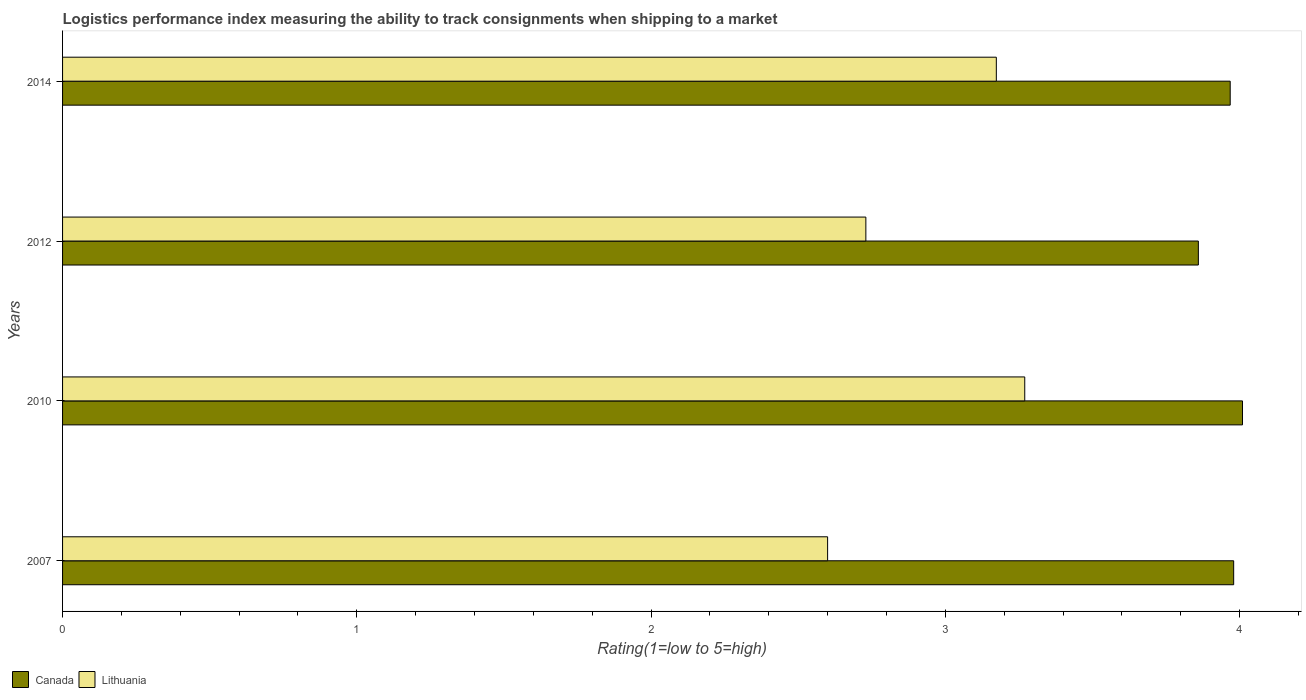How many groups of bars are there?
Provide a succinct answer. 4. Are the number of bars on each tick of the Y-axis equal?
Provide a succinct answer. Yes. How many bars are there on the 3rd tick from the top?
Ensure brevity in your answer.  2. In how many cases, is the number of bars for a given year not equal to the number of legend labels?
Keep it short and to the point. 0. What is the Logistic performance index in Lithuania in 2012?
Your answer should be compact. 2.73. Across all years, what is the maximum Logistic performance index in Canada?
Your response must be concise. 4.01. Across all years, what is the minimum Logistic performance index in Canada?
Provide a short and direct response. 3.86. In which year was the Logistic performance index in Canada minimum?
Keep it short and to the point. 2012. What is the total Logistic performance index in Lithuania in the graph?
Your response must be concise. 11.77. What is the difference between the Logistic performance index in Lithuania in 2010 and that in 2012?
Offer a terse response. 0.54. What is the difference between the Logistic performance index in Lithuania in 2014 and the Logistic performance index in Canada in 2007?
Provide a short and direct response. -0.81. What is the average Logistic performance index in Canada per year?
Make the answer very short. 3.95. In the year 2014, what is the difference between the Logistic performance index in Lithuania and Logistic performance index in Canada?
Keep it short and to the point. -0.79. What is the ratio of the Logistic performance index in Lithuania in 2007 to that in 2014?
Your answer should be compact. 0.82. What is the difference between the highest and the second highest Logistic performance index in Canada?
Provide a succinct answer. 0.03. What is the difference between the highest and the lowest Logistic performance index in Canada?
Keep it short and to the point. 0.15. In how many years, is the Logistic performance index in Canada greater than the average Logistic performance index in Canada taken over all years?
Ensure brevity in your answer.  3. What does the 2nd bar from the top in 2010 represents?
Offer a very short reply. Canada. What does the 2nd bar from the bottom in 2007 represents?
Keep it short and to the point. Lithuania. How many bars are there?
Make the answer very short. 8. How many years are there in the graph?
Offer a terse response. 4. Are the values on the major ticks of X-axis written in scientific E-notation?
Give a very brief answer. No. Does the graph contain any zero values?
Provide a short and direct response. No. Does the graph contain grids?
Provide a succinct answer. No. How many legend labels are there?
Offer a very short reply. 2. What is the title of the graph?
Your response must be concise. Logistics performance index measuring the ability to track consignments when shipping to a market. What is the label or title of the X-axis?
Offer a terse response. Rating(1=low to 5=high). What is the label or title of the Y-axis?
Ensure brevity in your answer.  Years. What is the Rating(1=low to 5=high) in Canada in 2007?
Provide a short and direct response. 3.98. What is the Rating(1=low to 5=high) in Canada in 2010?
Keep it short and to the point. 4.01. What is the Rating(1=low to 5=high) in Lithuania in 2010?
Your answer should be compact. 3.27. What is the Rating(1=low to 5=high) of Canada in 2012?
Keep it short and to the point. 3.86. What is the Rating(1=low to 5=high) of Lithuania in 2012?
Ensure brevity in your answer.  2.73. What is the Rating(1=low to 5=high) in Canada in 2014?
Offer a terse response. 3.97. What is the Rating(1=low to 5=high) of Lithuania in 2014?
Ensure brevity in your answer.  3.17. Across all years, what is the maximum Rating(1=low to 5=high) in Canada?
Offer a very short reply. 4.01. Across all years, what is the maximum Rating(1=low to 5=high) in Lithuania?
Offer a terse response. 3.27. Across all years, what is the minimum Rating(1=low to 5=high) in Canada?
Your answer should be very brief. 3.86. What is the total Rating(1=low to 5=high) of Canada in the graph?
Offer a terse response. 15.82. What is the total Rating(1=low to 5=high) of Lithuania in the graph?
Keep it short and to the point. 11.77. What is the difference between the Rating(1=low to 5=high) of Canada in 2007 and that in 2010?
Ensure brevity in your answer.  -0.03. What is the difference between the Rating(1=low to 5=high) in Lithuania in 2007 and that in 2010?
Provide a short and direct response. -0.67. What is the difference between the Rating(1=low to 5=high) of Canada in 2007 and that in 2012?
Provide a short and direct response. 0.12. What is the difference between the Rating(1=low to 5=high) of Lithuania in 2007 and that in 2012?
Your answer should be very brief. -0.13. What is the difference between the Rating(1=low to 5=high) of Canada in 2007 and that in 2014?
Provide a succinct answer. 0.01. What is the difference between the Rating(1=low to 5=high) in Lithuania in 2007 and that in 2014?
Provide a short and direct response. -0.57. What is the difference between the Rating(1=low to 5=high) in Lithuania in 2010 and that in 2012?
Give a very brief answer. 0.54. What is the difference between the Rating(1=low to 5=high) in Canada in 2010 and that in 2014?
Give a very brief answer. 0.04. What is the difference between the Rating(1=low to 5=high) in Lithuania in 2010 and that in 2014?
Provide a short and direct response. 0.1. What is the difference between the Rating(1=low to 5=high) of Canada in 2012 and that in 2014?
Provide a succinct answer. -0.11. What is the difference between the Rating(1=low to 5=high) in Lithuania in 2012 and that in 2014?
Make the answer very short. -0.44. What is the difference between the Rating(1=low to 5=high) in Canada in 2007 and the Rating(1=low to 5=high) in Lithuania in 2010?
Offer a very short reply. 0.71. What is the difference between the Rating(1=low to 5=high) of Canada in 2007 and the Rating(1=low to 5=high) of Lithuania in 2012?
Offer a terse response. 1.25. What is the difference between the Rating(1=low to 5=high) in Canada in 2007 and the Rating(1=low to 5=high) in Lithuania in 2014?
Ensure brevity in your answer.  0.81. What is the difference between the Rating(1=low to 5=high) in Canada in 2010 and the Rating(1=low to 5=high) in Lithuania in 2012?
Offer a terse response. 1.28. What is the difference between the Rating(1=low to 5=high) of Canada in 2010 and the Rating(1=low to 5=high) of Lithuania in 2014?
Offer a very short reply. 0.84. What is the difference between the Rating(1=low to 5=high) of Canada in 2012 and the Rating(1=low to 5=high) of Lithuania in 2014?
Provide a short and direct response. 0.69. What is the average Rating(1=low to 5=high) in Canada per year?
Ensure brevity in your answer.  3.95. What is the average Rating(1=low to 5=high) of Lithuania per year?
Ensure brevity in your answer.  2.94. In the year 2007, what is the difference between the Rating(1=low to 5=high) in Canada and Rating(1=low to 5=high) in Lithuania?
Provide a short and direct response. 1.38. In the year 2010, what is the difference between the Rating(1=low to 5=high) of Canada and Rating(1=low to 5=high) of Lithuania?
Provide a succinct answer. 0.74. In the year 2012, what is the difference between the Rating(1=low to 5=high) in Canada and Rating(1=low to 5=high) in Lithuania?
Offer a terse response. 1.13. In the year 2014, what is the difference between the Rating(1=low to 5=high) of Canada and Rating(1=low to 5=high) of Lithuania?
Ensure brevity in your answer.  0.79. What is the ratio of the Rating(1=low to 5=high) in Lithuania in 2007 to that in 2010?
Make the answer very short. 0.8. What is the ratio of the Rating(1=low to 5=high) in Canada in 2007 to that in 2012?
Provide a short and direct response. 1.03. What is the ratio of the Rating(1=low to 5=high) in Canada in 2007 to that in 2014?
Your response must be concise. 1. What is the ratio of the Rating(1=low to 5=high) in Lithuania in 2007 to that in 2014?
Give a very brief answer. 0.82. What is the ratio of the Rating(1=low to 5=high) in Canada in 2010 to that in 2012?
Your answer should be very brief. 1.04. What is the ratio of the Rating(1=low to 5=high) of Lithuania in 2010 to that in 2012?
Provide a short and direct response. 1.2. What is the ratio of the Rating(1=low to 5=high) in Canada in 2010 to that in 2014?
Keep it short and to the point. 1.01. What is the ratio of the Rating(1=low to 5=high) of Lithuania in 2010 to that in 2014?
Offer a terse response. 1.03. What is the ratio of the Rating(1=low to 5=high) of Canada in 2012 to that in 2014?
Offer a terse response. 0.97. What is the ratio of the Rating(1=low to 5=high) in Lithuania in 2012 to that in 2014?
Provide a succinct answer. 0.86. What is the difference between the highest and the second highest Rating(1=low to 5=high) of Canada?
Ensure brevity in your answer.  0.03. What is the difference between the highest and the second highest Rating(1=low to 5=high) in Lithuania?
Give a very brief answer. 0.1. What is the difference between the highest and the lowest Rating(1=low to 5=high) of Lithuania?
Your response must be concise. 0.67. 